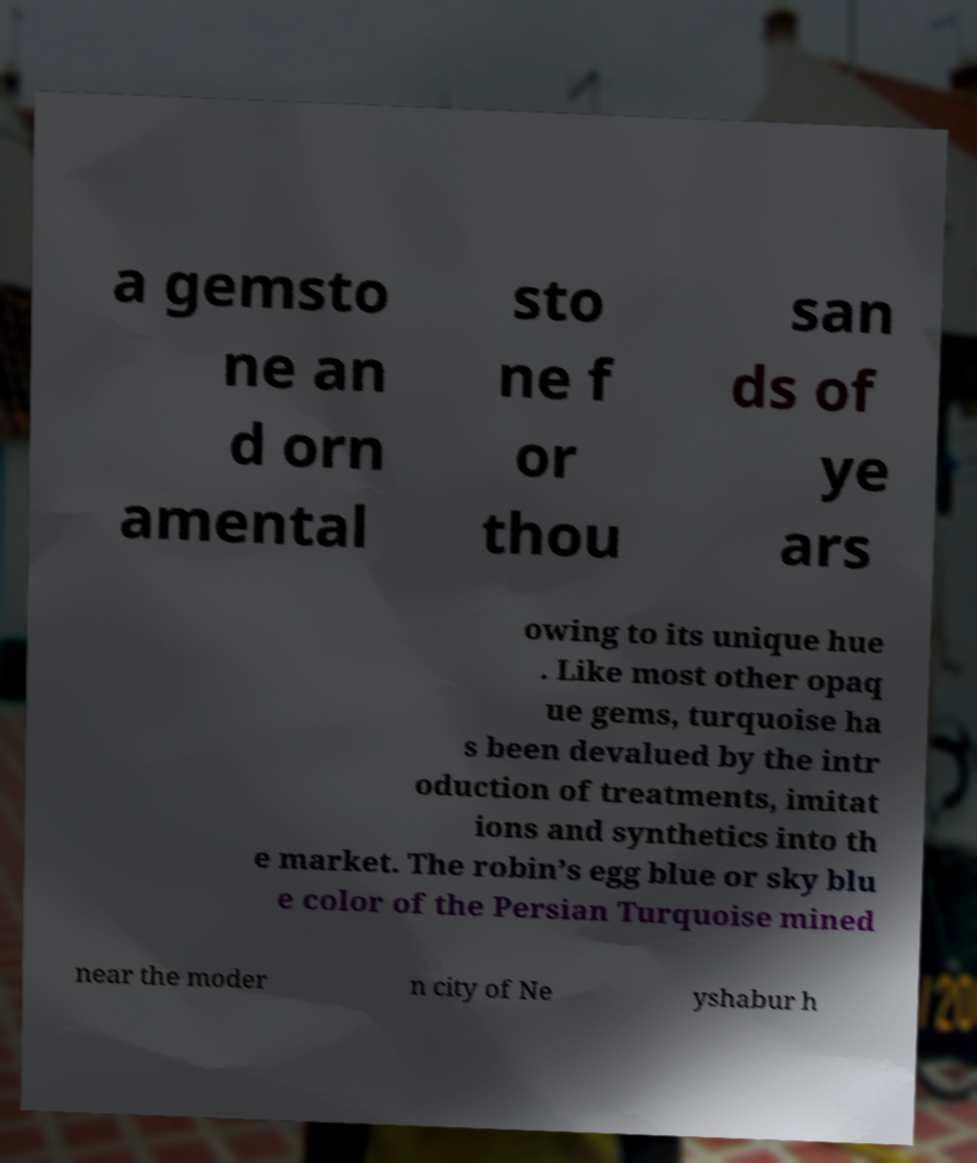There's text embedded in this image that I need extracted. Can you transcribe it verbatim? a gemsto ne an d orn amental sto ne f or thou san ds of ye ars owing to its unique hue . Like most other opaq ue gems, turquoise ha s been devalued by the intr oduction of treatments, imitat ions and synthetics into th e market. The robin’s egg blue or sky blu e color of the Persian Turquoise mined near the moder n city of Ne yshabur h 